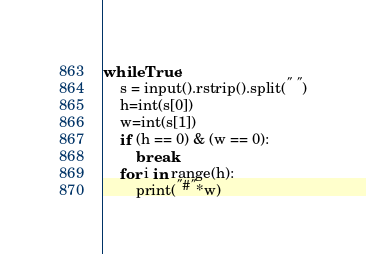<code> <loc_0><loc_0><loc_500><loc_500><_Python_>while True:
    s = input().rstrip().split(" ")
    h=int(s[0])
    w=int(s[1])
    if (h == 0) & (w == 0):
        break
    for i in range(h): 
        print("#"*w)</code> 